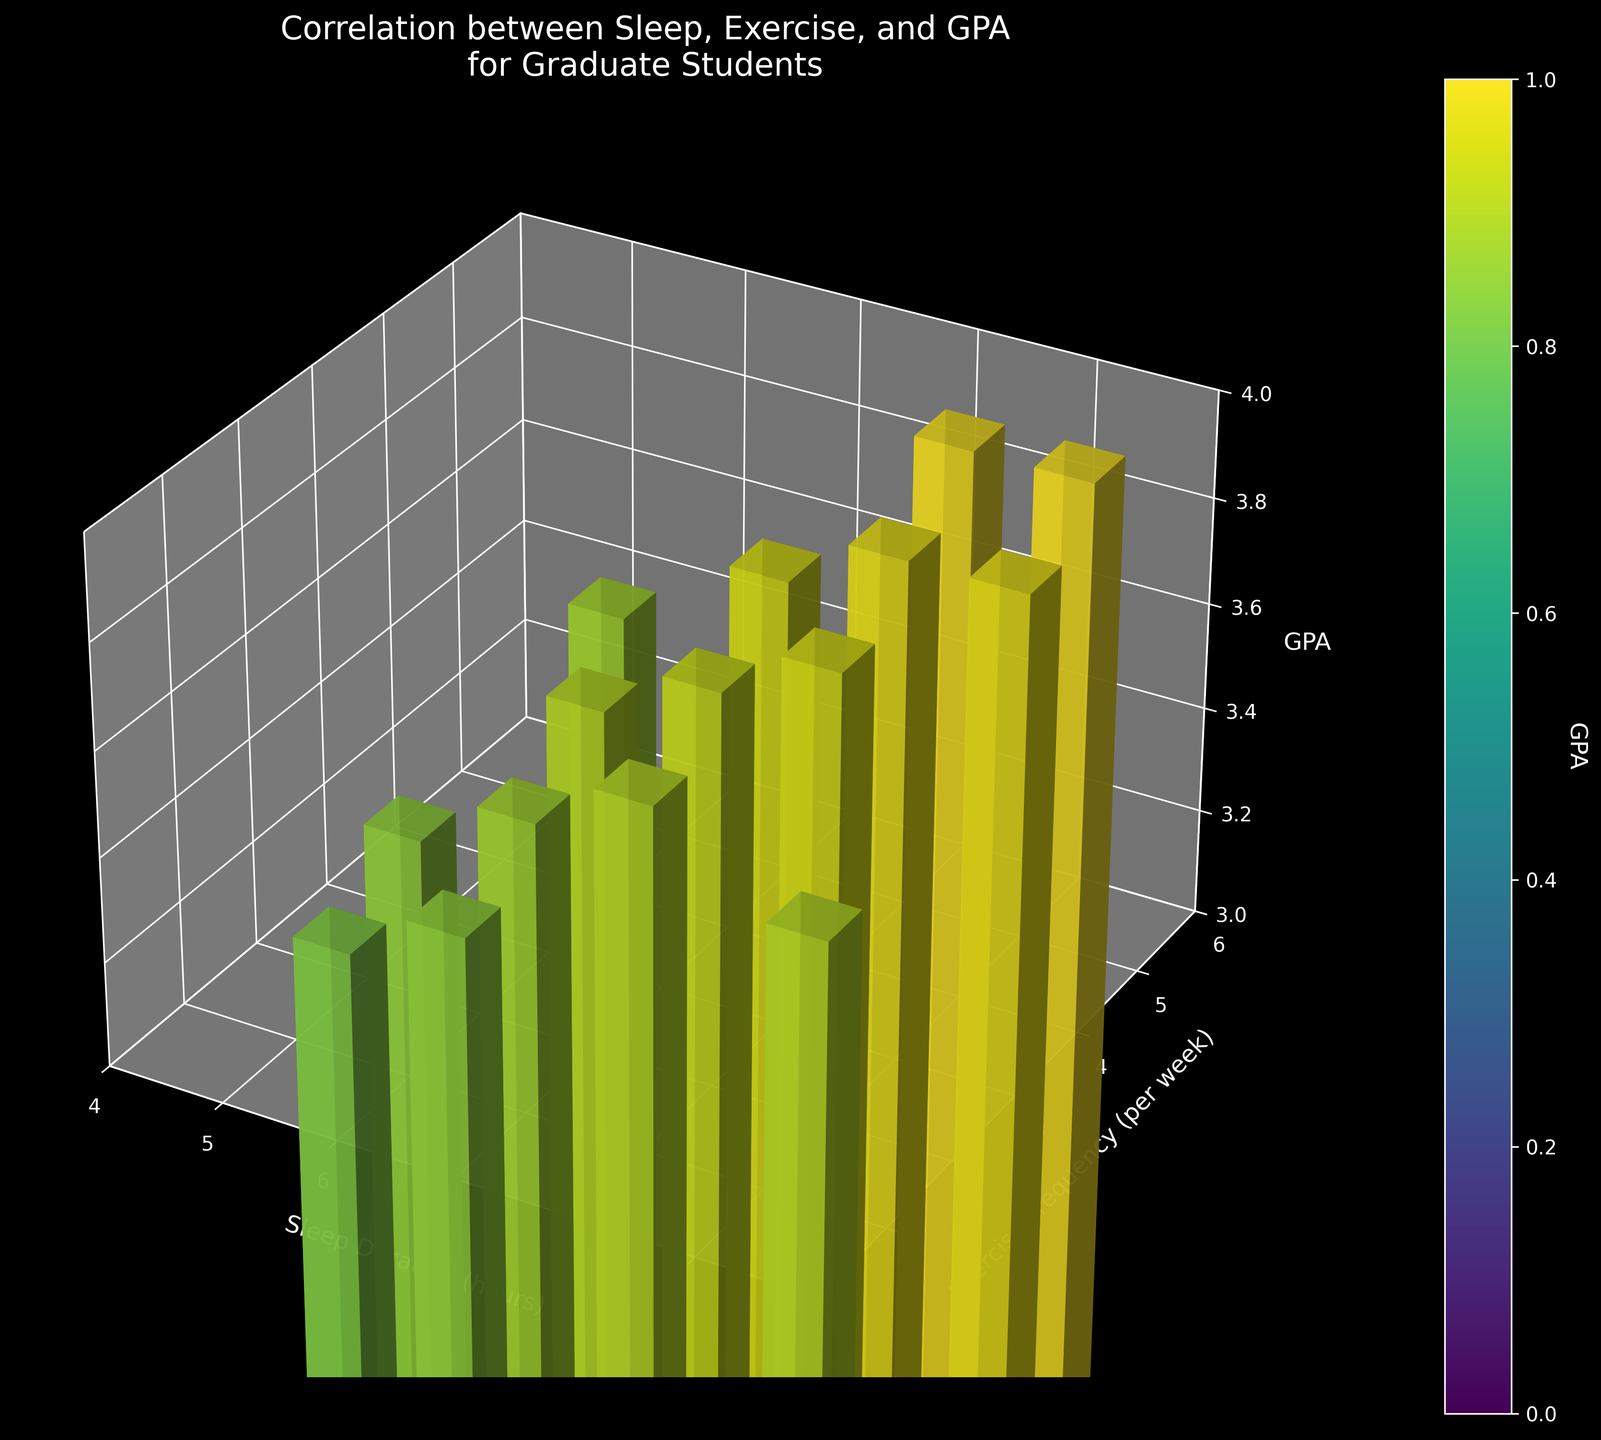What is the title of the figure? The title is usually displayed at the top of the figure and provides a summary of the subject matter. In this case, the title is "Correlation between Sleep, Exercise, and GPA\nfor Graduate Students."
Answer: Correlation between Sleep, Exercise, and GPA for Graduate Students What are the labels on the x-axis, y-axis, and z-axis? Figure axes are labeled to indicate what data they represent. For this plot, the x-axis is labeled "Sleep Duration (hours)," the y-axis is labeled "Exercise Frequency (per week)," and the z-axis is labeled "GPA."
Answer: Sleep Duration (hours), Exercise Frequency (per week), GPA How many data points are displayed in the plot? The bars in the 3D plot represent the data points. By counting the bars, we can determine that there are 15 data points.
Answer: 15 Which sleep duration has the highest GPA recorded? To determine this, we need to find the tallest bar (highest GPA) and check the corresponding Sleep Duration. The tallest bar corresponds to a GPA of 3.9, associated with 8 and 9 hours of sleep duration.
Answer: 8 and 9 hours Does any exercise frequency result in a GPA lower than 3.4? We need to identify if there is a bar on the plot with a GPA lower than 3.4 and check the corresponding Exercise Frequency. There is one data point at Exercise Frequency 1 with a GPA of 3.2.
Answer: Yes What is the average GPA for students who sleep 7 hours? We need to find all bars corresponding to the sleep duration of 7 hours and calculate the average of their GPA values (3.6, 3.5, 3.7). The average GPA is calculated as (3.6 + 3.5 + 3.7)/3 = 3.6.
Answer: 3.6 Which combination of sleep duration and exercise frequency produced the lowest GPA? We need to find the bar with the smallest height representing the lowest GPA and check the corresponding Sleep Duration and Exercise Frequency. The lowest GPA (3.2) occurred with 5 hours of sleep and 1 time of exercise per week.
Answer: 5 hours of sleep and 1 time of exercise per week Does exercising more frequently always lead to a higher GPA based on this plot? We need to check if there's a consistent increase in GPA with increasing exercise frequency across all sleep durations. Several bars show variable GPAs at different exercise frequencies. For instance, GPA varies for Exercise Frequency 1 (3.2, 3.3, 3.5, 3.8, 3.9). Thus, exercising more frequently does not always lead to a higher GPA.
Answer: No Is there a case where a student with lower sleep duration has a higher GPA than one with a higher sleep duration? We need to compare the bars for different sleep durations to check for any instances where a lower sleep duration corresponds to a higher GPA than a higher sleep duration. For example, a student with 8 hours of sleep and a GPA of 3.8 has a higher GPA than a student with 9 hours of sleep and a GPA of 3.5.
Answer: Yes What pattern can be observed regarding the GPA values and their colors? The color gradient indicates the GPA values, where bars with higher GPAs have colors from the 'viridis' colormap towards yellow and green, and lower GPAs lean towards blue. Thus, GPA values increase gradually from blue to yellow-green.
Answer: GPA increases from blue to yellow-green 